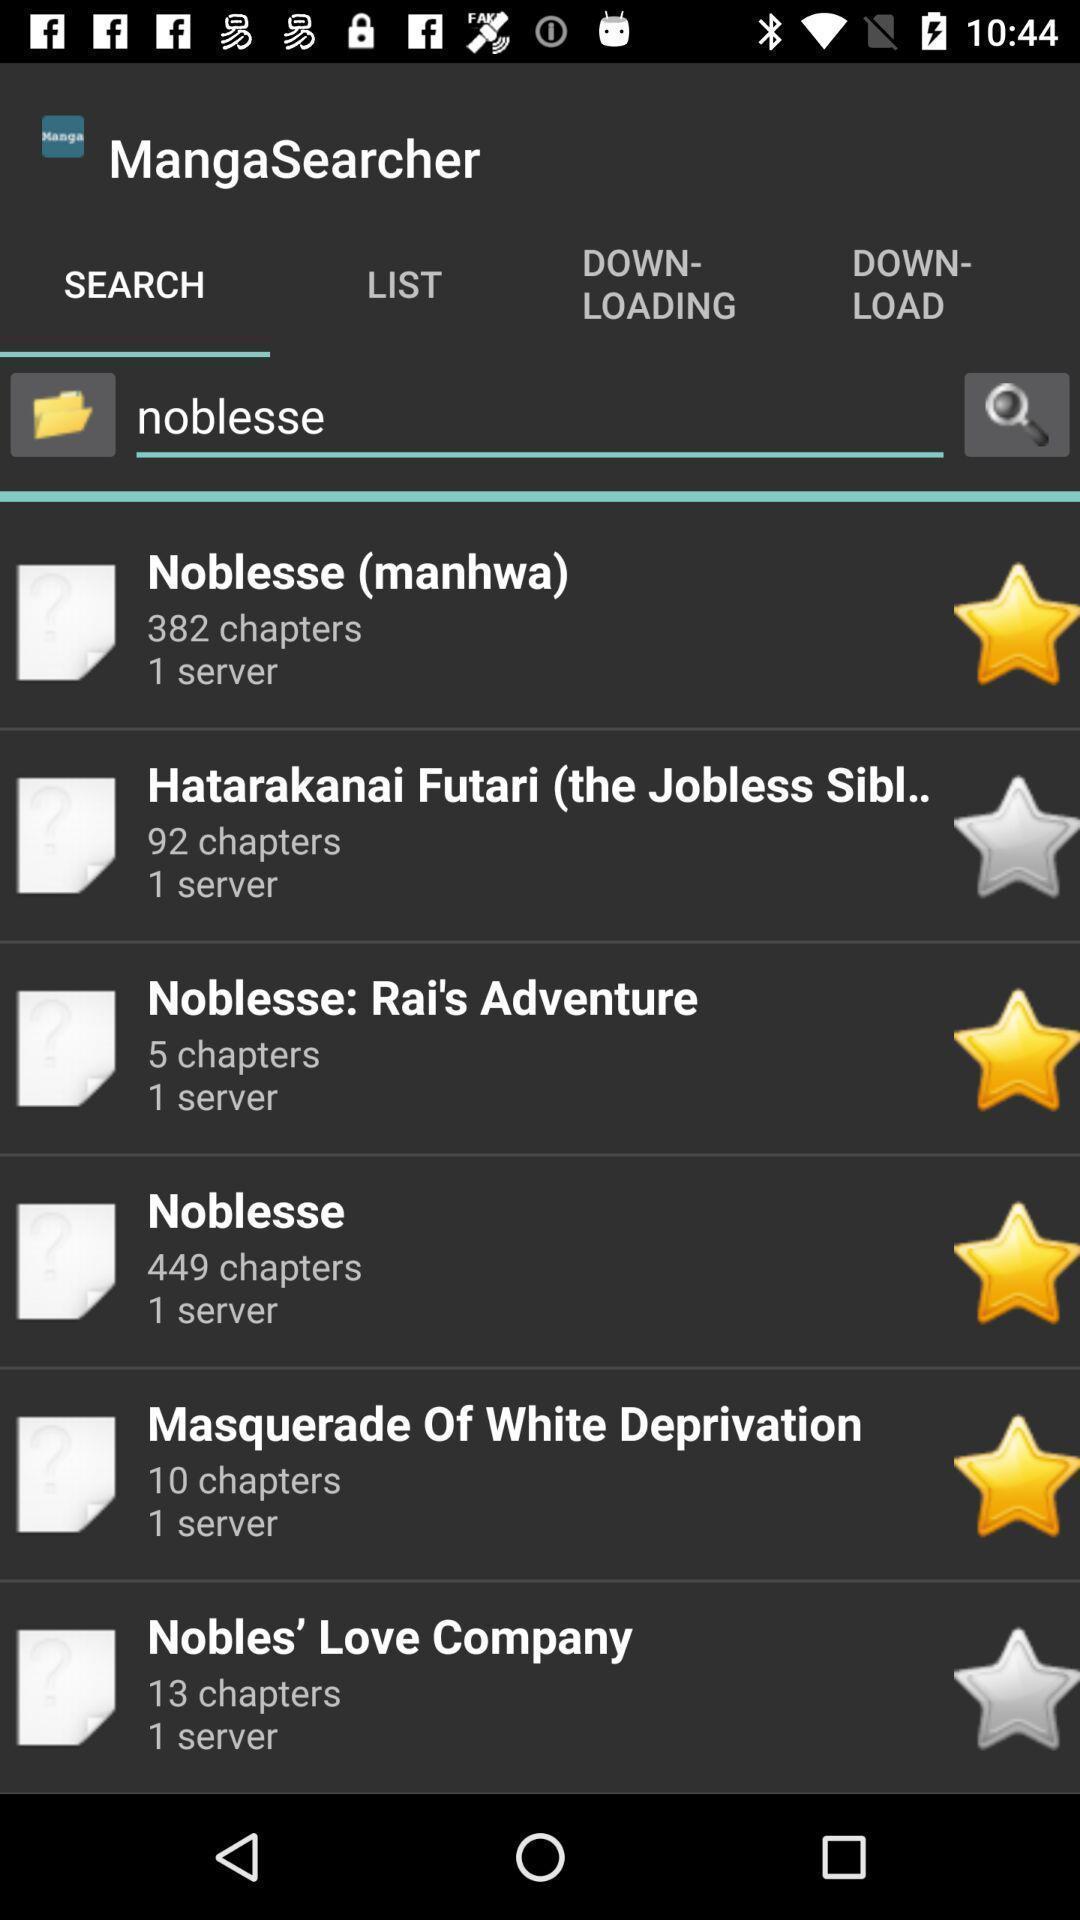Describe the key features of this screenshot. Search bar to find books. 